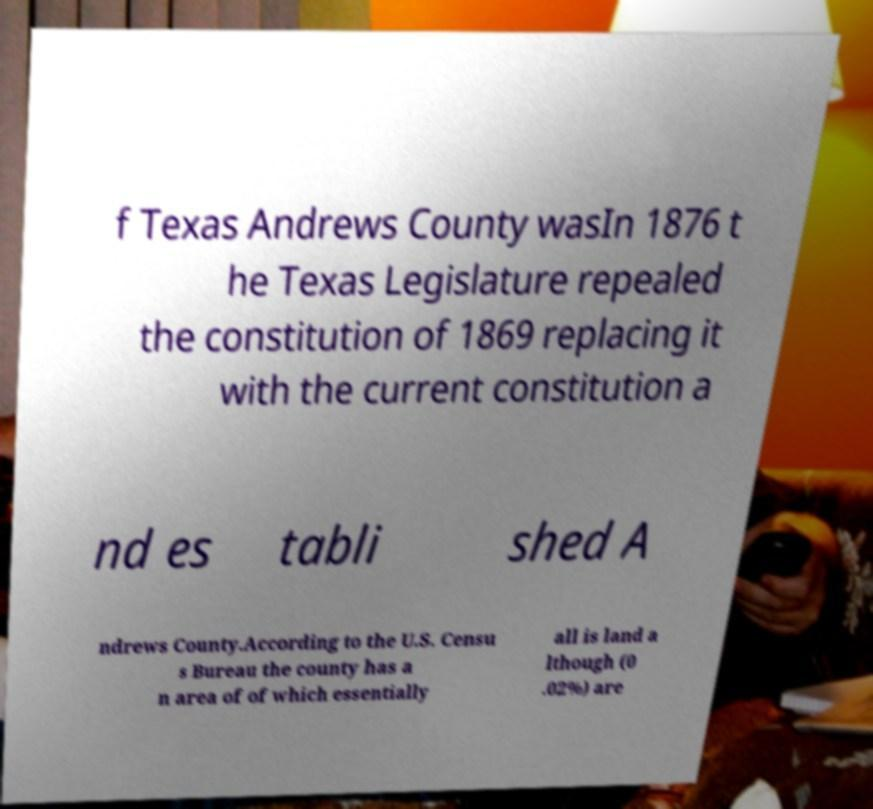Can you read and provide the text displayed in the image?This photo seems to have some interesting text. Can you extract and type it out for me? f Texas Andrews County wasIn 1876 t he Texas Legislature repealed the constitution of 1869 replacing it with the current constitution a nd es tabli shed A ndrews County.According to the U.S. Censu s Bureau the county has a n area of of which essentially all is land a lthough (0 .02%) are 